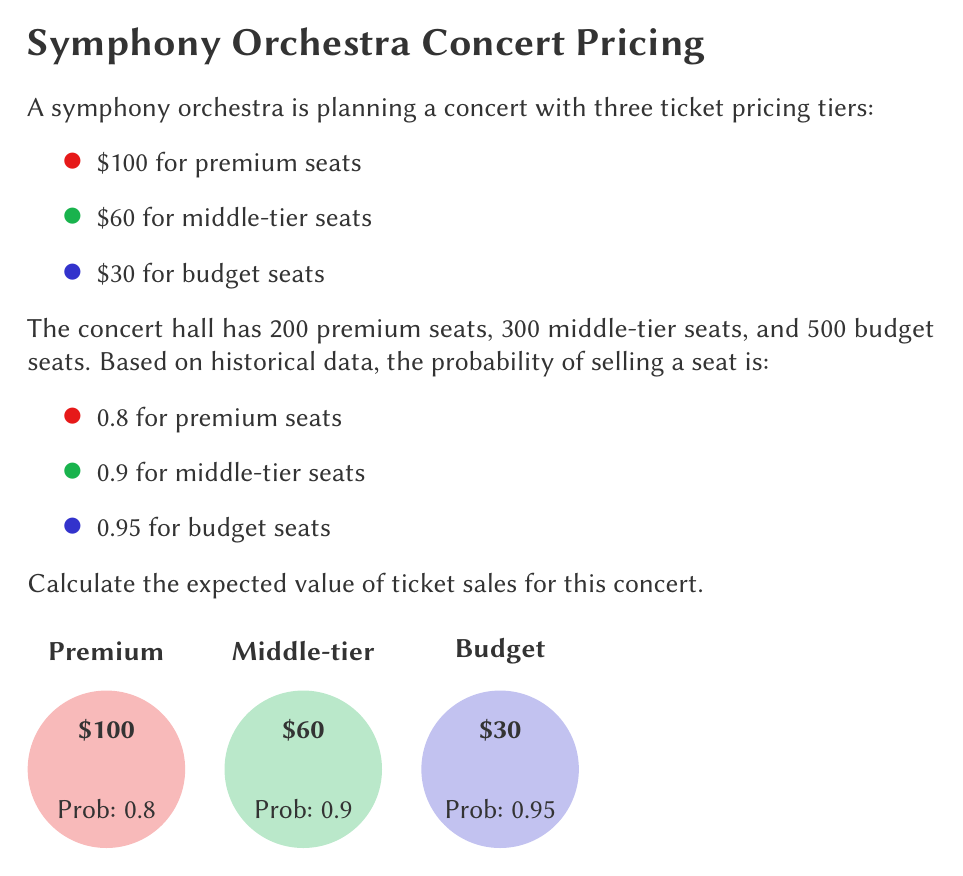Teach me how to tackle this problem. Let's approach this step-by-step:

1) First, we need to calculate the expected value for each ticket tier. The formula for expected value is:

   $E(X) = p \cdot v$

   Where $p$ is the probability of the event occurring, and $v$ is the value if it occurs.

2) For premium seats:
   $E(X_{premium}) = 0.8 \cdot 100 \cdot 200 = $16,000$

3) For middle-tier seats:
   $E(X_{middle}) = 0.9 \cdot 60 \cdot 300 = $16,200$

4) For budget seats:
   $E(X_{budget}) = 0.95 \cdot 30 \cdot 500 = $14,250$

5) The total expected value is the sum of these three:

   $E(X_{total}) = E(X_{premium}) + E(X_{middle}) + E(X_{budget})$

   $E(X_{total}) = 16,000 + 16,200 + 14,250 = $46,450$

Therefore, the expected value of ticket sales for this concert is $46,450.
Answer: $46,450 